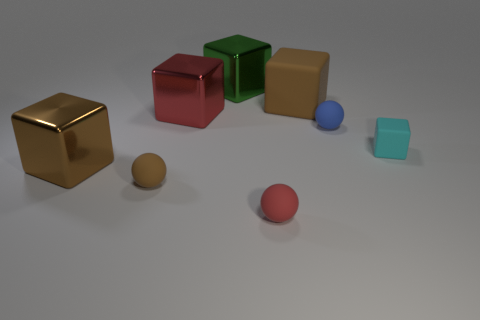Is there any other thing that is the same color as the big matte block?
Offer a terse response. Yes. There is a big block left of the small rubber sphere that is on the left side of the red thing on the right side of the big green metal cube; what is its material?
Offer a terse response. Metal. What number of metal things are either large green objects or big brown objects?
Provide a succinct answer. 2. How many brown things are either big objects or rubber things?
Make the answer very short. 3. Do the rubber thing on the left side of the large green thing and the big matte block have the same color?
Your response must be concise. Yes. Are the red ball and the brown ball made of the same material?
Your answer should be compact. Yes. Is the number of metallic things to the left of the red cube the same as the number of tiny brown rubber balls that are on the right side of the blue matte object?
Give a very brief answer. No. There is a red thing that is the same shape as the tiny brown thing; what material is it?
Your answer should be very brief. Rubber. What shape is the brown matte object that is on the left side of the brown object that is behind the cyan object right of the small brown rubber ball?
Your answer should be compact. Sphere. Are there more brown metal things behind the small cyan object than large blue spheres?
Give a very brief answer. No. 